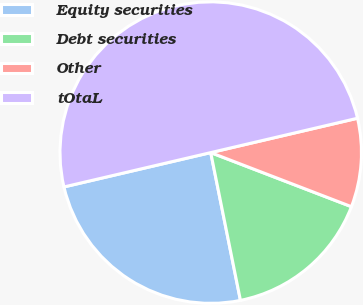<chart> <loc_0><loc_0><loc_500><loc_500><pie_chart><fcel>Equity securities<fcel>Debt securities<fcel>Other<fcel>tOtaL<nl><fcel>24.5%<fcel>16.0%<fcel>9.5%<fcel>50.0%<nl></chart> 